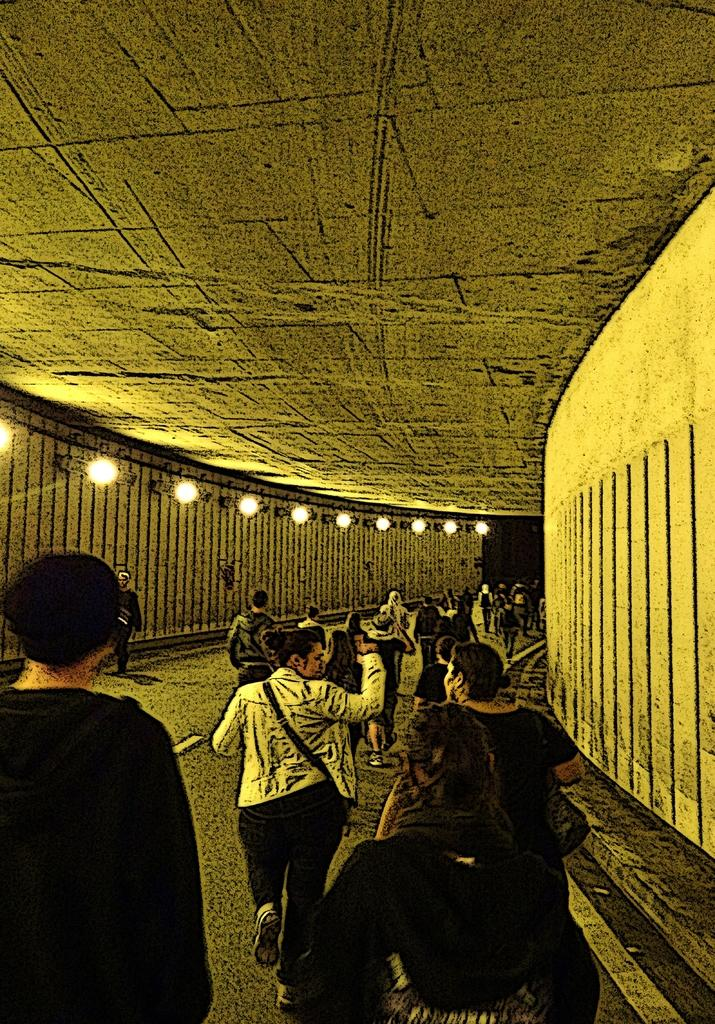What is the main subject of the image? The main subject of the image is a tunnel. What can be seen inside the tunnel? There is a group of people in the tunnel. What surrounds the people in the tunnel? There are walls on both sides of the people. What can be seen to the left in the image? There are lights visible to the left. What role does the actor play in the memory of the dad in the image? There is no dad or actor present in the image, and therefore no such memory can be observed. 